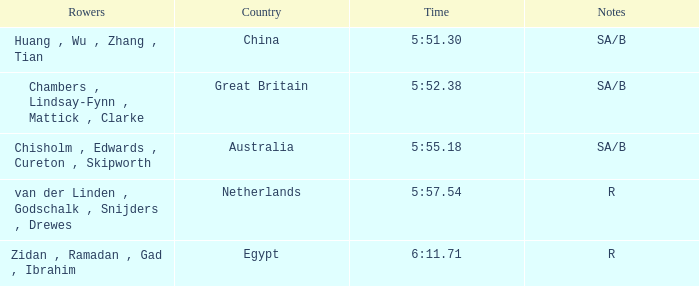30? Huang , Wu , Zhang , Tian. 